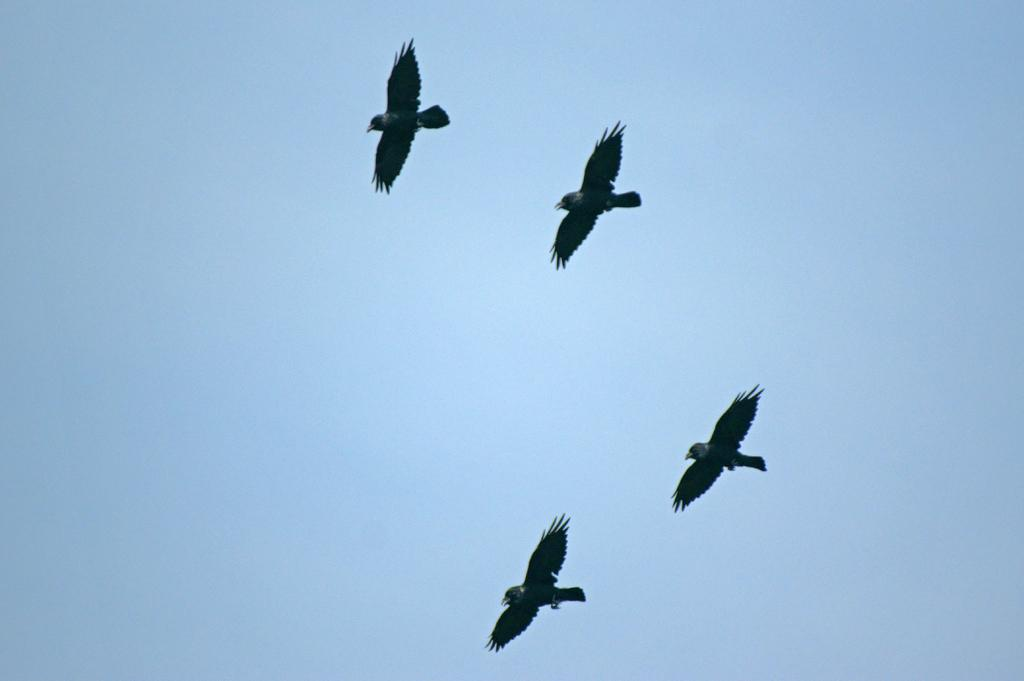How many birds are visible in the image? There are four birds in the sky. What type of game is being played by the birds in the image? There is no game being played by the birds in the image, as it is a still image and not a video or animation. 